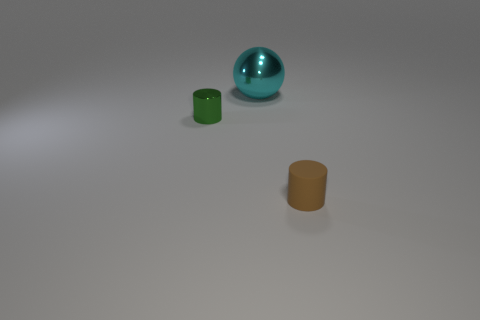What could be the setting where these objects are located? The objects are situated on a plain surface under consistent lighting, suggesting they might be placed in a controlled environment, like a studio or a tabletop for photography or display purposes. 